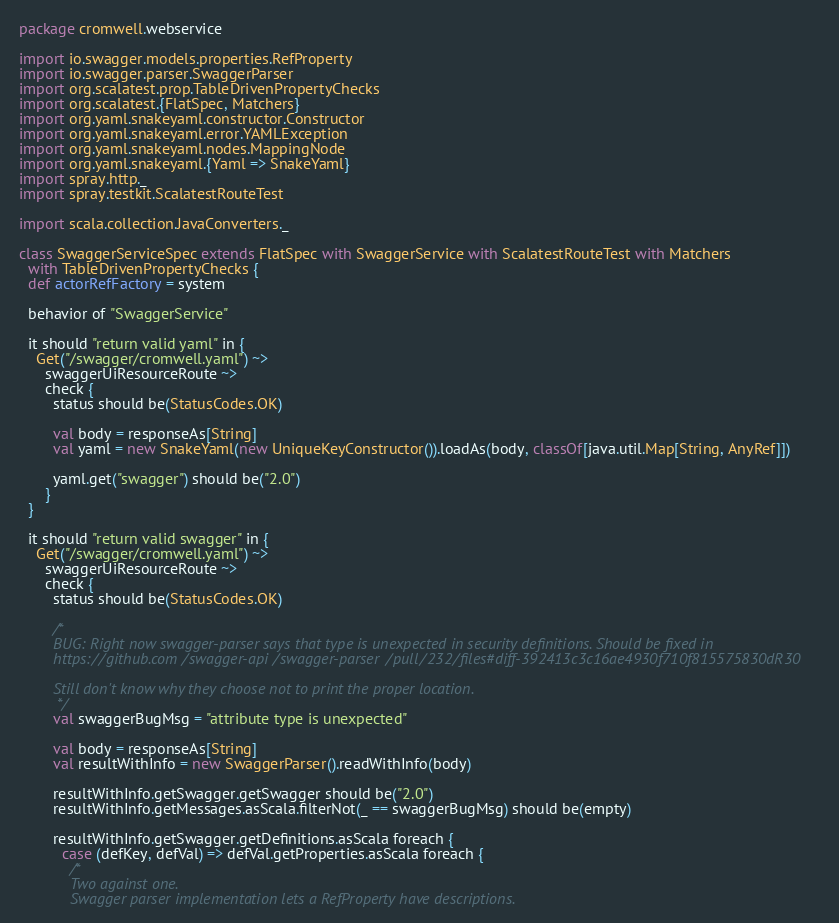Convert code to text. <code><loc_0><loc_0><loc_500><loc_500><_Scala_>package cromwell.webservice

import io.swagger.models.properties.RefProperty
import io.swagger.parser.SwaggerParser
import org.scalatest.prop.TableDrivenPropertyChecks
import org.scalatest.{FlatSpec, Matchers}
import org.yaml.snakeyaml.constructor.Constructor
import org.yaml.snakeyaml.error.YAMLException
import org.yaml.snakeyaml.nodes.MappingNode
import org.yaml.snakeyaml.{Yaml => SnakeYaml}
import spray.http._
import spray.testkit.ScalatestRouteTest

import scala.collection.JavaConverters._

class SwaggerServiceSpec extends FlatSpec with SwaggerService with ScalatestRouteTest with Matchers
  with TableDrivenPropertyChecks {
  def actorRefFactory = system

  behavior of "SwaggerService"

  it should "return valid yaml" in {
    Get("/swagger/cromwell.yaml") ~>
      swaggerUiResourceRoute ~>
      check {
        status should be(StatusCodes.OK)

        val body = responseAs[String]
        val yaml = new SnakeYaml(new UniqueKeyConstructor()).loadAs(body, classOf[java.util.Map[String, AnyRef]])

        yaml.get("swagger") should be("2.0")
      }
  }

  it should "return valid swagger" in {
    Get("/swagger/cromwell.yaml") ~>
      swaggerUiResourceRoute ~>
      check {
        status should be(StatusCodes.OK)

        /*
        BUG: Right now swagger-parser says that type is unexpected in security definitions. Should be fixed in
        https://github.com/swagger-api/swagger-parser/pull/232/files#diff-392413c3c16ae4930f710f815575830dR30

        Still don't know why they choose not to print the proper location.
         */
        val swaggerBugMsg = "attribute type is unexpected"

        val body = responseAs[String]
        val resultWithInfo = new SwaggerParser().readWithInfo(body)

        resultWithInfo.getSwagger.getSwagger should be("2.0")
        resultWithInfo.getMessages.asScala.filterNot(_ == swaggerBugMsg) should be(empty)

        resultWithInfo.getSwagger.getDefinitions.asScala foreach {
          case (defKey, defVal) => defVal.getProperties.asScala foreach {
            /*
            Two against one.
            Swagger parser implementation lets a RefProperty have descriptions.</code> 